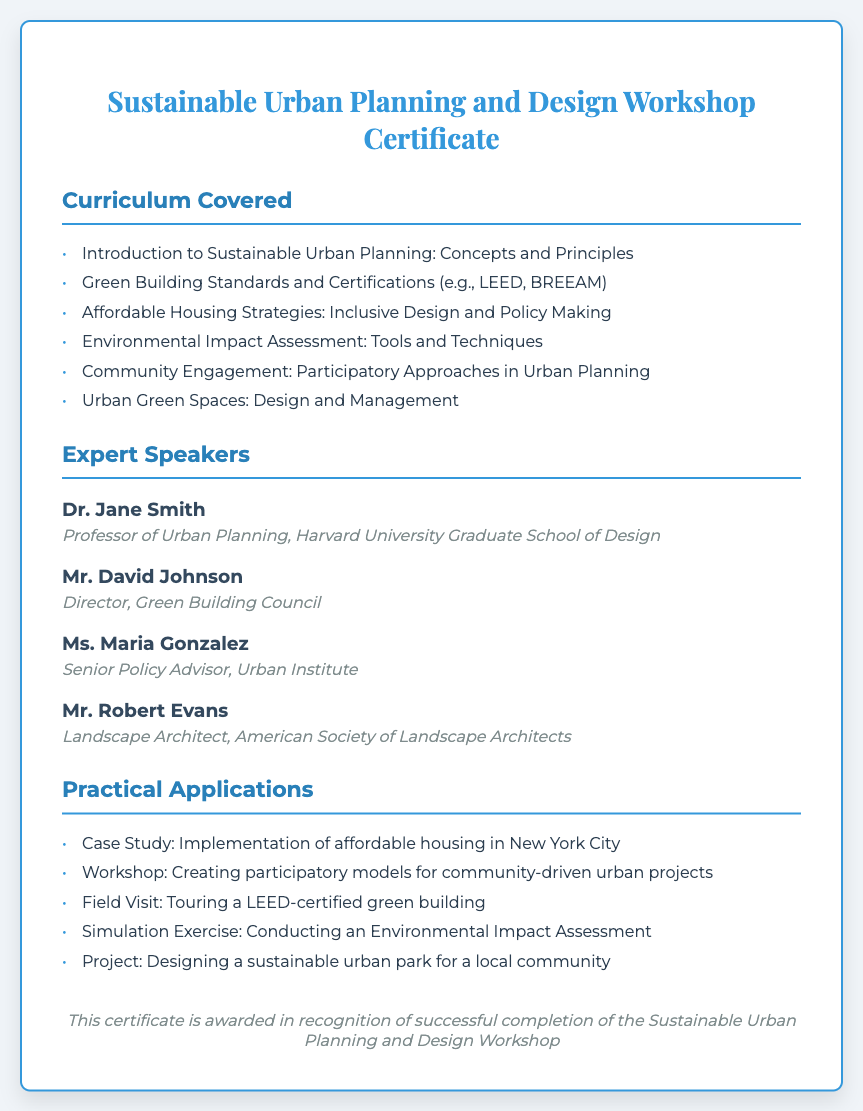What is the title of the certificate? The title of the certificate is explicitly stated at the top of the document.
Answer: Sustainable Urban Planning and Design Workshop Certificate Who is the speaker from Harvard University? The document lists speakers along with their affiliations, specifically noting the university they are associated with.
Answer: Dr. Jane Smith What is one of the green building certifications mentioned? The curriculum outlines various standards including notable certifications relevant to sustainable urban planning.
Answer: LEED How many expert speakers are listed in the document? The document enumerates the speakers in the expert speakers section.
Answer: 4 What is one practical application highlighted in the workshop? The section on practical applications provides examples of hands-on learning experiences included in the workshop.
Answer: Case Study: Implementation of affordable housing in New York City Which principle is included in the curriculum covered? The curriculum section lists core concepts central to sustainable urban planning.
Answer: Concepts and Principles What is the role of Maria Gonzalez? The document describes roles and affiliations of each speaker to contextualize their expertise.
Answer: Senior Policy Advisor What kind of exercise is included in the practical applications? Practical applications section indicates various experiential tasks students might undertake in the workshop.
Answer: Simulation Exercise: Conducting an Environmental Impact Assessment What is the color of the certificate border? The design elements are clearly mentioned, including the aesthetic features of the certificate like colors.
Answer: #3498db 